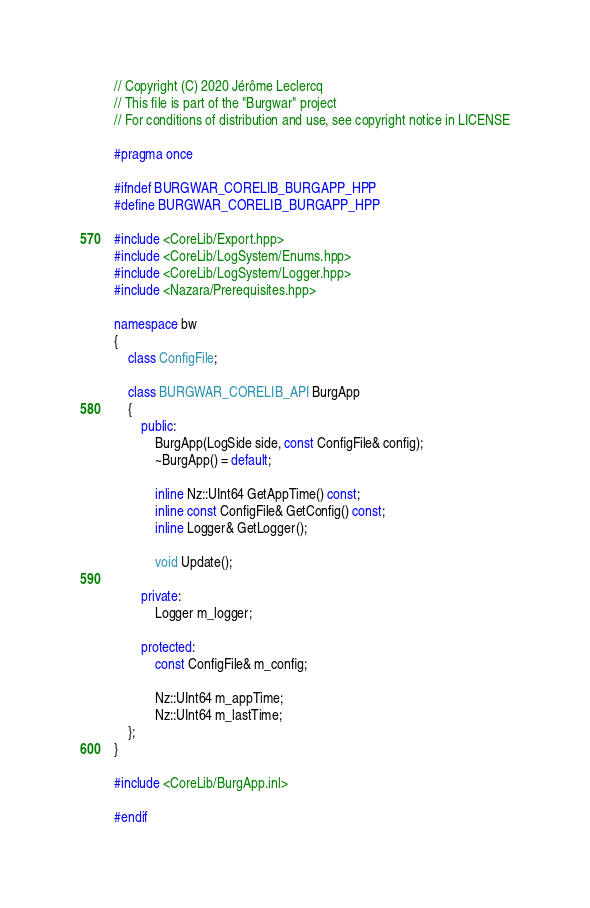<code> <loc_0><loc_0><loc_500><loc_500><_C++_>// Copyright (C) 2020 Jérôme Leclercq
// This file is part of the "Burgwar" project
// For conditions of distribution and use, see copyright notice in LICENSE

#pragma once

#ifndef BURGWAR_CORELIB_BURGAPP_HPP
#define BURGWAR_CORELIB_BURGAPP_HPP

#include <CoreLib/Export.hpp>
#include <CoreLib/LogSystem/Enums.hpp>
#include <CoreLib/LogSystem/Logger.hpp>
#include <Nazara/Prerequisites.hpp>

namespace bw
{
	class ConfigFile;

	class BURGWAR_CORELIB_API BurgApp
	{
		public:
			BurgApp(LogSide side, const ConfigFile& config);
			~BurgApp() = default;

			inline Nz::UInt64 GetAppTime() const;
			inline const ConfigFile& GetConfig() const;
			inline Logger& GetLogger();

			void Update();

		private:
			Logger m_logger;

		protected:
			const ConfigFile& m_config;

			Nz::UInt64 m_appTime;
			Nz::UInt64 m_lastTime;
	};
}

#include <CoreLib/BurgApp.inl>

#endif
</code> 